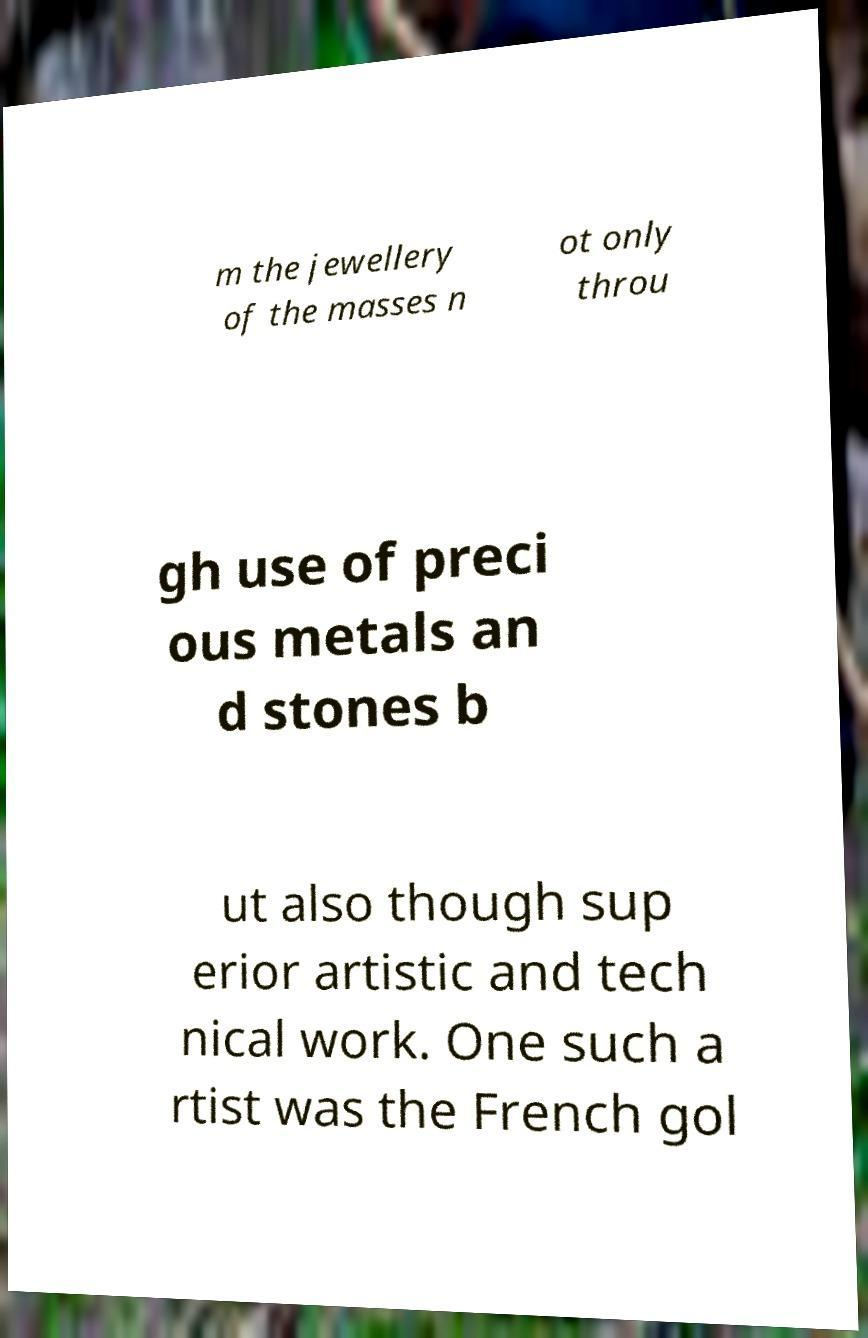Can you read and provide the text displayed in the image?This photo seems to have some interesting text. Can you extract and type it out for me? m the jewellery of the masses n ot only throu gh use of preci ous metals an d stones b ut also though sup erior artistic and tech nical work. One such a rtist was the French gol 